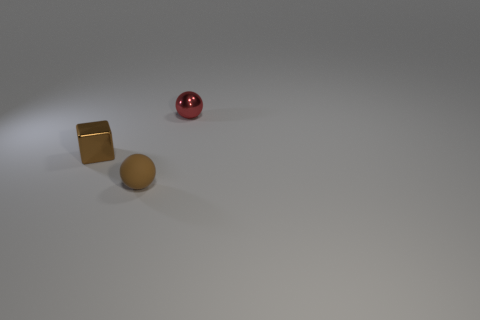What are the possible materials of the objects displayed? The objects in the image seem to be made of different materials. The spherical object has a reflective surface suggesting it could be metallic, possibly painted or anodized to achieve the red color. The cube-shaped block appears to have a metallic luster as well, potentially brass or gold-plated metal given its color. The rounded object near the cube may be made of a matte material like stone or ceramic, due to its non-reflective texture. 